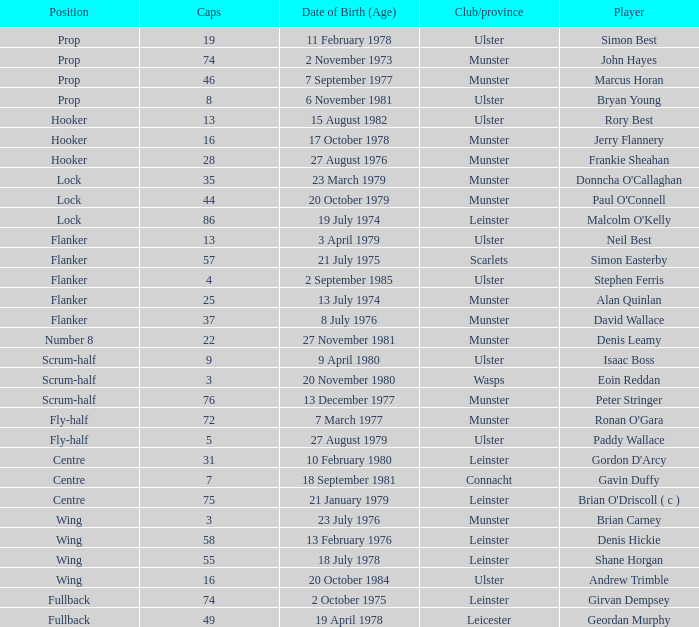I'm looking to parse the entire table for insights. Could you assist me with that? {'header': ['Position', 'Caps', 'Date of Birth (Age)', 'Club/province', 'Player'], 'rows': [['Prop', '19', '11 February 1978', 'Ulster', 'Simon Best'], ['Prop', '74', '2 November 1973', 'Munster', 'John Hayes'], ['Prop', '46', '7 September 1977', 'Munster', 'Marcus Horan'], ['Prop', '8', '6 November 1981', 'Ulster', 'Bryan Young'], ['Hooker', '13', '15 August 1982', 'Ulster', 'Rory Best'], ['Hooker', '16', '17 October 1978', 'Munster', 'Jerry Flannery'], ['Hooker', '28', '27 August 1976', 'Munster', 'Frankie Sheahan'], ['Lock', '35', '23 March 1979', 'Munster', "Donncha O'Callaghan"], ['Lock', '44', '20 October 1979', 'Munster', "Paul O'Connell"], ['Lock', '86', '19 July 1974', 'Leinster', "Malcolm O'Kelly"], ['Flanker', '13', '3 April 1979', 'Ulster', 'Neil Best'], ['Flanker', '57', '21 July 1975', 'Scarlets', 'Simon Easterby'], ['Flanker', '4', '2 September 1985', 'Ulster', 'Stephen Ferris'], ['Flanker', '25', '13 July 1974', 'Munster', 'Alan Quinlan'], ['Flanker', '37', '8 July 1976', 'Munster', 'David Wallace'], ['Number 8', '22', '27 November 1981', 'Munster', 'Denis Leamy'], ['Scrum-half', '9', '9 April 1980', 'Ulster', 'Isaac Boss'], ['Scrum-half', '3', '20 November 1980', 'Wasps', 'Eoin Reddan'], ['Scrum-half', '76', '13 December 1977', 'Munster', 'Peter Stringer'], ['Fly-half', '72', '7 March 1977', 'Munster', "Ronan O'Gara"], ['Fly-half', '5', '27 August 1979', 'Ulster', 'Paddy Wallace'], ['Centre', '31', '10 February 1980', 'Leinster', "Gordon D'Arcy"], ['Centre', '7', '18 September 1981', 'Connacht', 'Gavin Duffy'], ['Centre', '75', '21 January 1979', 'Leinster', "Brian O'Driscoll ( c )"], ['Wing', '3', '23 July 1976', 'Munster', 'Brian Carney'], ['Wing', '58', '13 February 1976', 'Leinster', 'Denis Hickie'], ['Wing', '55', '18 July 1978', 'Leinster', 'Shane Horgan'], ['Wing', '16', '20 October 1984', 'Ulster', 'Andrew Trimble'], ['Fullback', '74', '2 October 1975', 'Leinster', 'Girvan Dempsey'], ['Fullback', '49', '19 April 1978', 'Leicester', 'Geordan Murphy']]} What is the club or province of Girvan Dempsey, who has 74 caps? Leinster. 